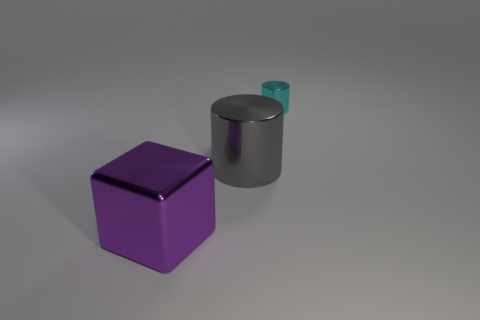Is the size of the metal cylinder on the right side of the gray metal cylinder the same as the cylinder that is in front of the small cyan cylinder?
Your answer should be compact. No. Is the number of purple shiny blocks on the right side of the purple shiny thing greater than the number of tiny cyan things on the right side of the small cyan metallic cylinder?
Provide a succinct answer. No. What is the color of the big shiny thing that is right of the large shiny thing that is to the left of the large gray shiny cylinder?
Keep it short and to the point. Gray. What number of balls are either gray shiny objects or cyan objects?
Offer a terse response. 0. What number of metallic objects are both right of the big metal block and to the left of the small cyan thing?
Offer a very short reply. 1. There is a cylinder to the left of the small cyan shiny cylinder; what color is it?
Provide a short and direct response. Gray. There is a cyan thing that is the same material as the large cylinder; what size is it?
Your response must be concise. Small. There is a large thing behind the large block; how many blocks are behind it?
Make the answer very short. 0. There is a big gray cylinder; what number of shiny cylinders are behind it?
Your answer should be very brief. 1. What is the color of the cylinder to the left of the cyan metal cylinder that is behind the big shiny object right of the large purple object?
Your answer should be very brief. Gray. 